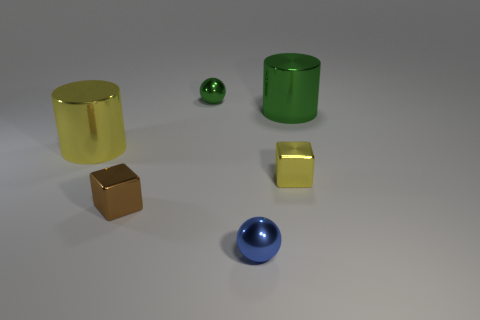Add 1 small yellow things. How many objects exist? 7 Subtract 1 cubes. How many cubes are left? 1 Subtract all red matte things. Subtract all small green shiny things. How many objects are left? 5 Add 3 small blue metal spheres. How many small blue metal spheres are left? 4 Add 5 cylinders. How many cylinders exist? 7 Subtract 0 gray balls. How many objects are left? 6 Subtract all brown cylinders. Subtract all red balls. How many cylinders are left? 2 